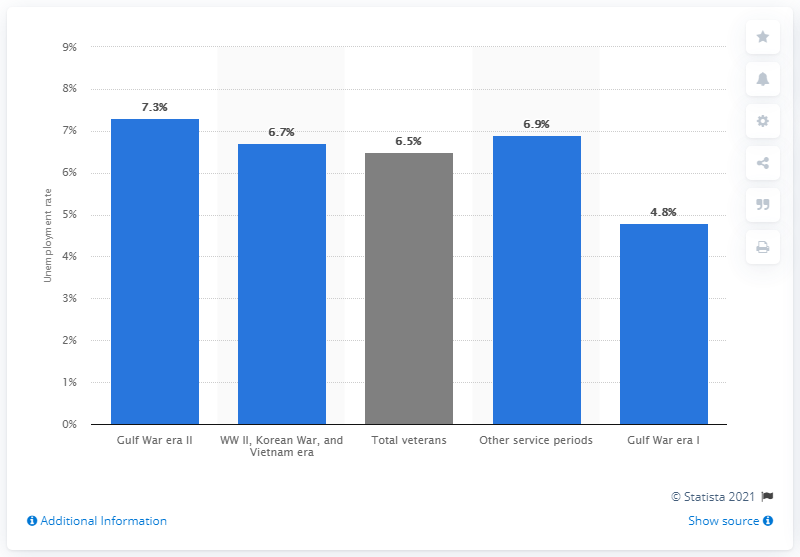Specify some key components in this picture. In 2020, a significant number of veterans who served in the Gulf War were unemployed, with 7.3% of this group reporting joblessness. 